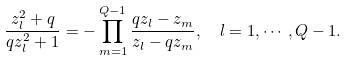Convert formula to latex. <formula><loc_0><loc_0><loc_500><loc_500>\frac { z _ { l } ^ { 2 } + q } { q z _ { l } ^ { 2 } + 1 } = - \prod _ { m = 1 } ^ { Q - 1 } \frac { q z _ { l } - z _ { m } } { z _ { l } - q z _ { m } } , \ \ l = 1 , \cdots , Q - 1 .</formula> 